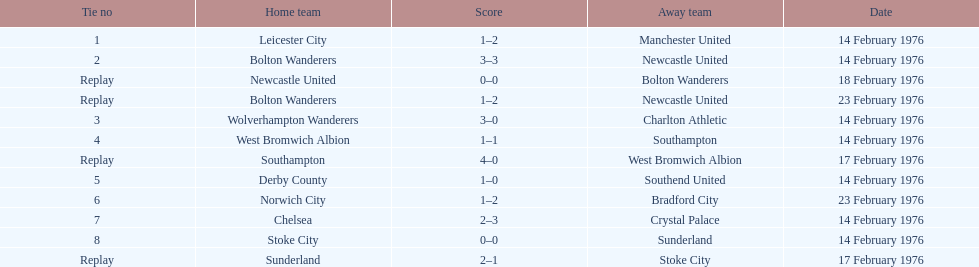How many games transpired on february 14, 1976? 7. 